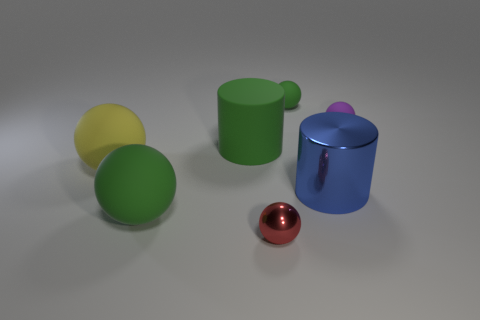Subtract all large yellow balls. How many balls are left? 4 Subtract all red spheres. How many spheres are left? 4 Subtract all brown spheres. Subtract all yellow blocks. How many spheres are left? 5 Add 2 metallic cylinders. How many objects exist? 9 Subtract all cylinders. How many objects are left? 5 Subtract all purple rubber balls. Subtract all red metal cylinders. How many objects are left? 6 Add 2 small green matte spheres. How many small green matte spheres are left? 3 Add 5 tiny purple objects. How many tiny purple objects exist? 6 Subtract 0 brown cylinders. How many objects are left? 7 